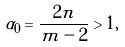Convert formula to latex. <formula><loc_0><loc_0><loc_500><loc_500>\alpha _ { 0 } = \frac { 2 n } { m - 2 } > 1 ,</formula> 